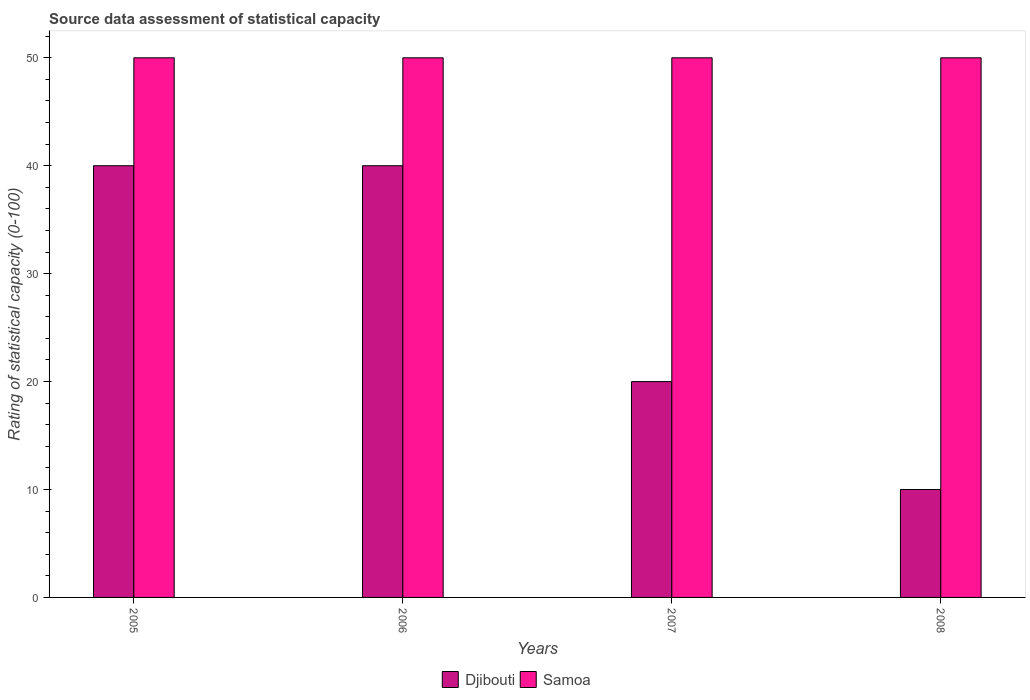How many bars are there on the 3rd tick from the left?
Provide a succinct answer. 2. In how many cases, is the number of bars for a given year not equal to the number of legend labels?
Give a very brief answer. 0. What is the rating of statistical capacity in Samoa in 2006?
Your answer should be compact. 50. In which year was the rating of statistical capacity in Djibouti minimum?
Your response must be concise. 2008. What is the total rating of statistical capacity in Djibouti in the graph?
Your answer should be very brief. 110. What is the difference between the rating of statistical capacity in Djibouti in 2006 and that in 2008?
Provide a succinct answer. 30. What is the difference between the rating of statistical capacity in Samoa in 2008 and the rating of statistical capacity in Djibouti in 2006?
Make the answer very short. 10. In how many years, is the rating of statistical capacity in Djibouti greater than 16?
Provide a succinct answer. 3. Is the rating of statistical capacity in Djibouti in 2005 less than that in 2007?
Your answer should be compact. No. What is the difference between the highest and the second highest rating of statistical capacity in Samoa?
Make the answer very short. 0. Is the sum of the rating of statistical capacity in Djibouti in 2005 and 2008 greater than the maximum rating of statistical capacity in Samoa across all years?
Your answer should be compact. No. What does the 2nd bar from the left in 2005 represents?
Your answer should be very brief. Samoa. What does the 1st bar from the right in 2008 represents?
Your answer should be very brief. Samoa. Are all the bars in the graph horizontal?
Your response must be concise. No. How many years are there in the graph?
Your answer should be compact. 4. What is the difference between two consecutive major ticks on the Y-axis?
Provide a short and direct response. 10. Are the values on the major ticks of Y-axis written in scientific E-notation?
Make the answer very short. No. Where does the legend appear in the graph?
Provide a short and direct response. Bottom center. How are the legend labels stacked?
Your response must be concise. Horizontal. What is the title of the graph?
Make the answer very short. Source data assessment of statistical capacity. What is the label or title of the Y-axis?
Your answer should be compact. Rating of statistical capacity (0-100). What is the Rating of statistical capacity (0-100) in Djibouti in 2006?
Your answer should be compact. 40. Across all years, what is the maximum Rating of statistical capacity (0-100) in Djibouti?
Make the answer very short. 40. Across all years, what is the maximum Rating of statistical capacity (0-100) in Samoa?
Provide a succinct answer. 50. Across all years, what is the minimum Rating of statistical capacity (0-100) of Samoa?
Provide a short and direct response. 50. What is the total Rating of statistical capacity (0-100) in Djibouti in the graph?
Offer a terse response. 110. What is the difference between the Rating of statistical capacity (0-100) in Djibouti in 2005 and that in 2006?
Offer a terse response. 0. What is the difference between the Rating of statistical capacity (0-100) in Samoa in 2005 and that in 2006?
Your response must be concise. 0. What is the difference between the Rating of statistical capacity (0-100) in Samoa in 2005 and that in 2007?
Keep it short and to the point. 0. What is the difference between the Rating of statistical capacity (0-100) of Djibouti in 2005 and that in 2008?
Your response must be concise. 30. What is the difference between the Rating of statistical capacity (0-100) in Djibouti in 2006 and that in 2008?
Offer a very short reply. 30. What is the difference between the Rating of statistical capacity (0-100) in Djibouti in 2007 and that in 2008?
Give a very brief answer. 10. What is the difference between the Rating of statistical capacity (0-100) of Samoa in 2007 and that in 2008?
Offer a very short reply. 0. What is the difference between the Rating of statistical capacity (0-100) in Djibouti in 2005 and the Rating of statistical capacity (0-100) in Samoa in 2008?
Provide a short and direct response. -10. What is the difference between the Rating of statistical capacity (0-100) in Djibouti in 2006 and the Rating of statistical capacity (0-100) in Samoa in 2008?
Give a very brief answer. -10. What is the average Rating of statistical capacity (0-100) of Djibouti per year?
Your answer should be very brief. 27.5. What is the average Rating of statistical capacity (0-100) of Samoa per year?
Your answer should be very brief. 50. In the year 2007, what is the difference between the Rating of statistical capacity (0-100) of Djibouti and Rating of statistical capacity (0-100) of Samoa?
Provide a succinct answer. -30. In the year 2008, what is the difference between the Rating of statistical capacity (0-100) in Djibouti and Rating of statistical capacity (0-100) in Samoa?
Provide a succinct answer. -40. What is the ratio of the Rating of statistical capacity (0-100) of Djibouti in 2005 to that in 2006?
Offer a very short reply. 1. What is the ratio of the Rating of statistical capacity (0-100) of Samoa in 2005 to that in 2006?
Make the answer very short. 1. What is the ratio of the Rating of statistical capacity (0-100) of Djibouti in 2005 to that in 2007?
Ensure brevity in your answer.  2. What is the ratio of the Rating of statistical capacity (0-100) in Djibouti in 2005 to that in 2008?
Provide a short and direct response. 4. What is the ratio of the Rating of statistical capacity (0-100) of Djibouti in 2006 to that in 2008?
Keep it short and to the point. 4. What is the ratio of the Rating of statistical capacity (0-100) in Samoa in 2006 to that in 2008?
Keep it short and to the point. 1. What is the ratio of the Rating of statistical capacity (0-100) of Djibouti in 2007 to that in 2008?
Give a very brief answer. 2. What is the ratio of the Rating of statistical capacity (0-100) of Samoa in 2007 to that in 2008?
Keep it short and to the point. 1. What is the difference between the highest and the second highest Rating of statistical capacity (0-100) in Djibouti?
Your answer should be very brief. 0. What is the difference between the highest and the second highest Rating of statistical capacity (0-100) in Samoa?
Make the answer very short. 0. What is the difference between the highest and the lowest Rating of statistical capacity (0-100) of Djibouti?
Make the answer very short. 30. What is the difference between the highest and the lowest Rating of statistical capacity (0-100) of Samoa?
Your response must be concise. 0. 